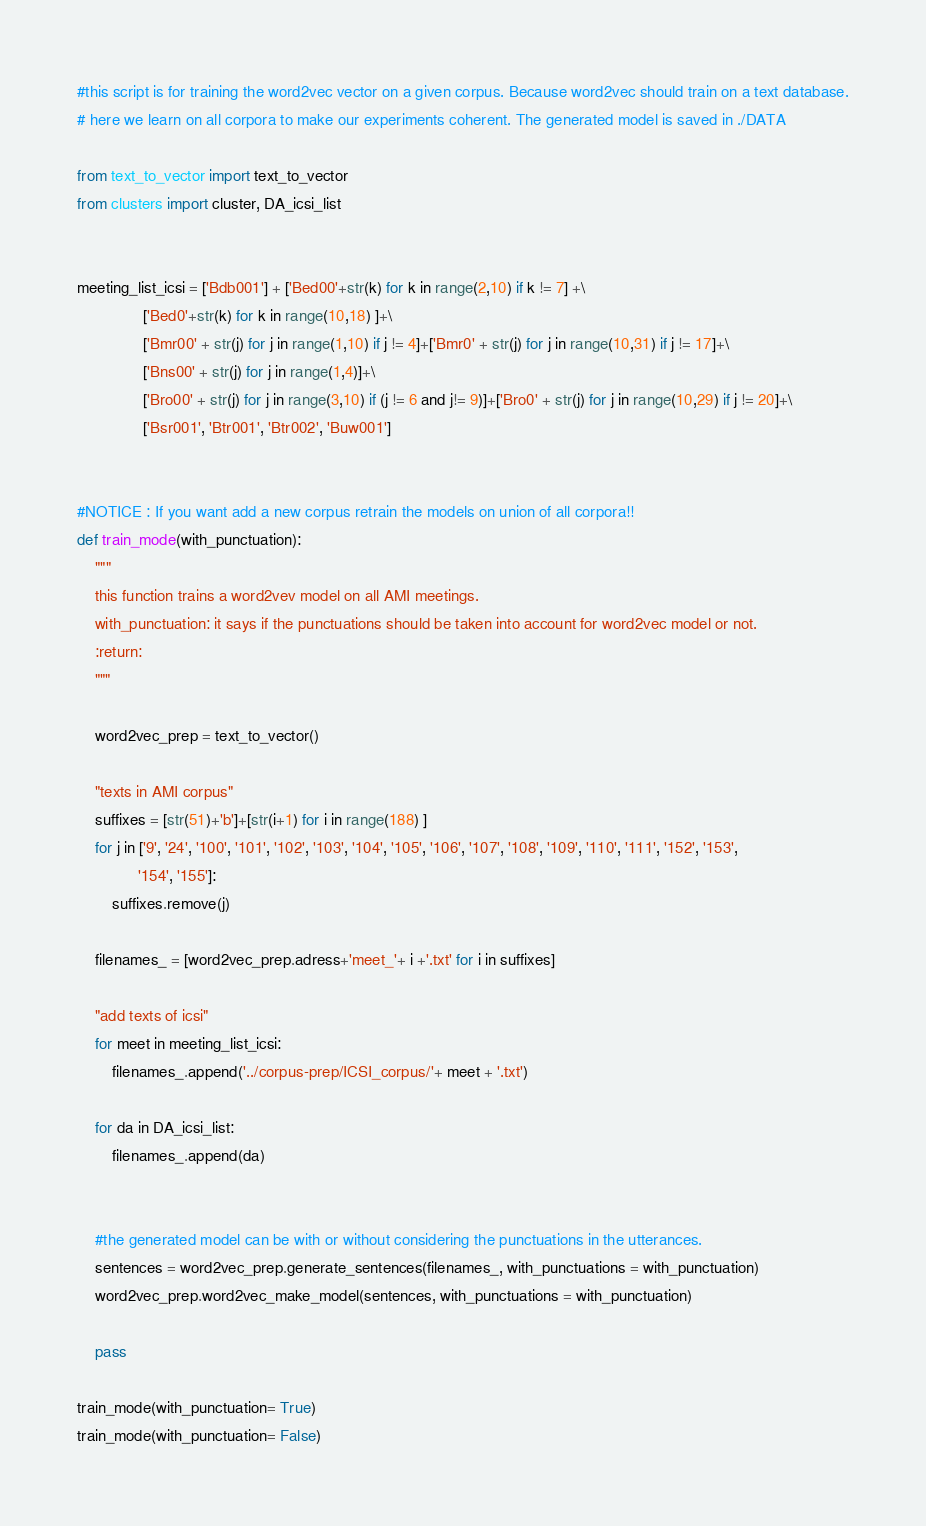Convert code to text. <code><loc_0><loc_0><loc_500><loc_500><_Python_>#this script is for training the word2vec vector on a given corpus. Because word2vec should train on a text database.
# here we learn on all corpora to make our experiments coherent. The generated model is saved in ./DATA

from text_to_vector import text_to_vector
from clusters import cluster, DA_icsi_list


meeting_list_icsi = ['Bdb001'] + ['Bed00'+str(k) for k in range(2,10) if k != 7] +\
               ['Bed0'+str(k) for k in range(10,18) ]+\
               ['Bmr00' + str(j) for j in range(1,10) if j != 4]+['Bmr0' + str(j) for j in range(10,31) if j != 17]+\
               ['Bns00' + str(j) for j in range(1,4)]+\
               ['Bro00' + str(j) for j in range(3,10) if (j != 6 and j!= 9)]+['Bro0' + str(j) for j in range(10,29) if j != 20]+\
               ['Bsr001', 'Btr001', 'Btr002', 'Buw001']


#NOTICE : If you want add a new corpus retrain the models on union of all corpora!!
def train_mode(with_punctuation):
    """
    this function trains a word2vev model on all AMI meetings.
    with_punctuation: it says if the punctuations should be taken into account for word2vec model or not.
    :return:
    """

    word2vec_prep = text_to_vector()

    "texts in AMI corpus"
    suffixes = [str(51)+'b']+[str(i+1) for i in range(188) ]
    for j in ['9', '24', '100', '101', '102', '103', '104', '105', '106', '107', '108', '109', '110', '111', '152', '153',
              '154', '155']:
        suffixes.remove(j)

    filenames_ = [word2vec_prep.adress+'meet_'+ i +'.txt' for i in suffixes]

    "add texts of icsi"
    for meet in meeting_list_icsi:
        filenames_.append('../corpus-prep/ICSI_corpus/'+ meet + '.txt')

    for da in DA_icsi_list:
        filenames_.append(da)


    #the generated model can be with or without considering the punctuations in the utterances.
    sentences = word2vec_prep.generate_sentences(filenames_, with_punctuations = with_punctuation)
    word2vec_prep.word2vec_make_model(sentences, with_punctuations = with_punctuation)

    pass

train_mode(with_punctuation= True)
train_mode(with_punctuation= False)</code> 